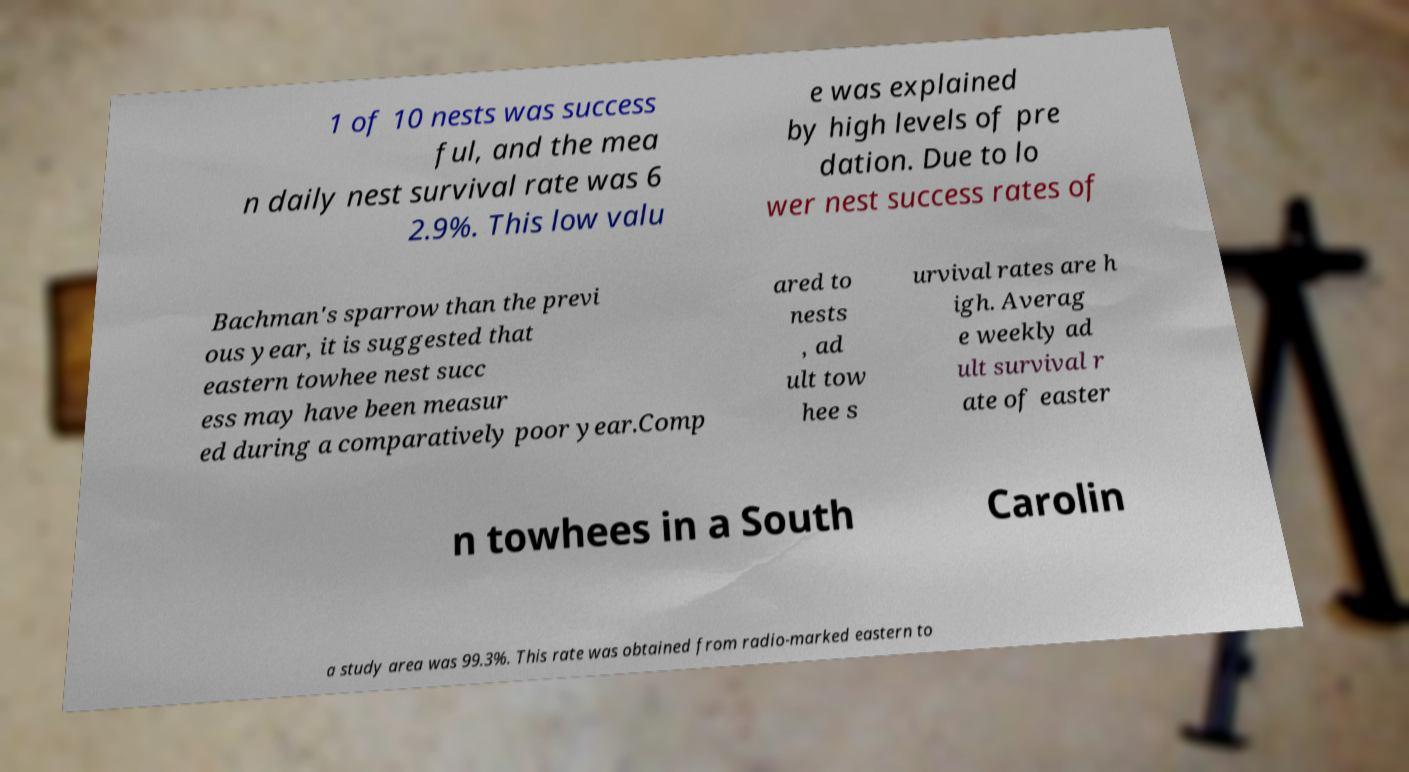I need the written content from this picture converted into text. Can you do that? 1 of 10 nests was success ful, and the mea n daily nest survival rate was 6 2.9%. This low valu e was explained by high levels of pre dation. Due to lo wer nest success rates of Bachman's sparrow than the previ ous year, it is suggested that eastern towhee nest succ ess may have been measur ed during a comparatively poor year.Comp ared to nests , ad ult tow hee s urvival rates are h igh. Averag e weekly ad ult survival r ate of easter n towhees in a South Carolin a study area was 99.3%. This rate was obtained from radio-marked eastern to 